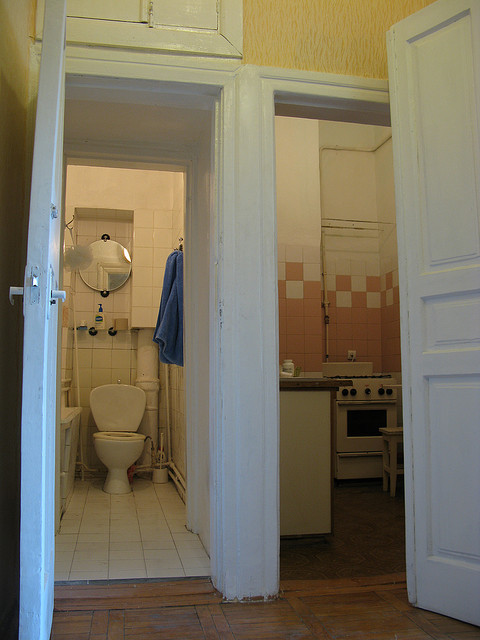What type of wood is on the floor? The flooring in the image appears to be a type of light-colored, possibly varnished wood, which is typical of hardwood varieties such as oak or ash. These materials are commonly used in residential spaces due to their durability and aesthetic appeal. 